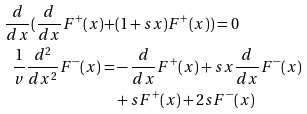<formula> <loc_0><loc_0><loc_500><loc_500>\frac { d } { d x } ( \frac { d } { d x } F ^ { + } ( x ) + & ( 1 + s x ) F ^ { + } ( x ) ) = 0 \\ \frac { 1 } { v } \frac { d ^ { 2 } } { d x ^ { 2 } } F ^ { - } ( x ) = & - \frac { d } { d x } F ^ { + } ( x ) + s x \frac { d } { d x } F ^ { - } ( x ) \\ & + s F ^ { + } ( x ) + 2 s F ^ { - } ( x )</formula> 